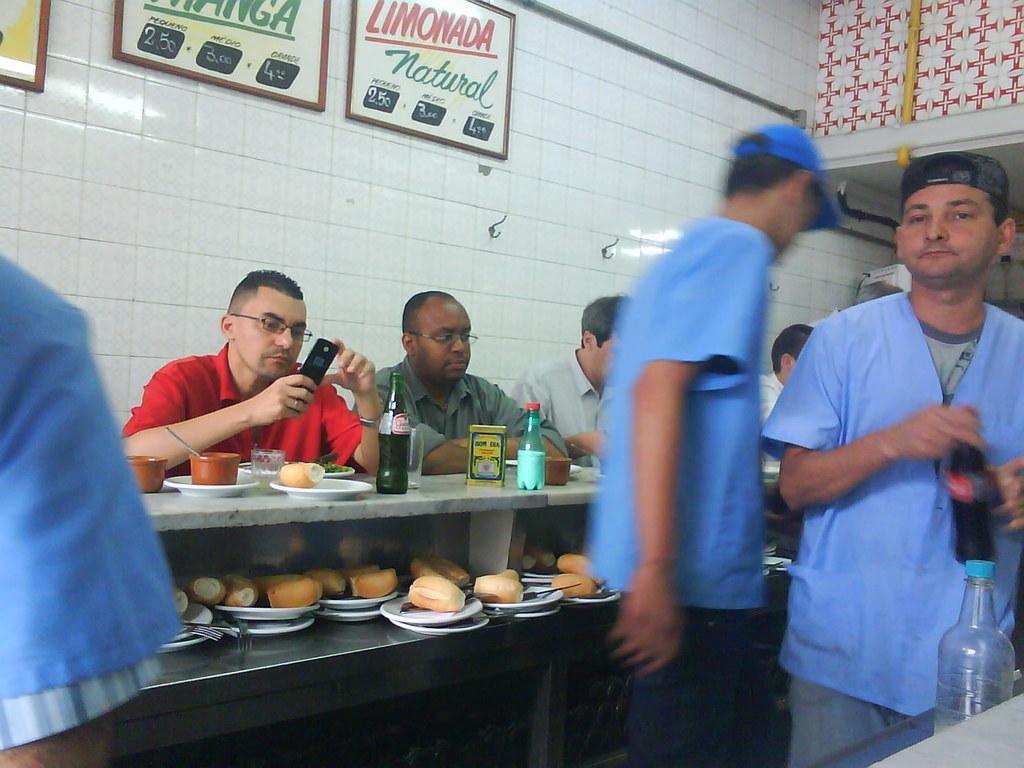Could you give a brief overview of what you see in this image? It looks like a cafe there are some people sitting in front of the table and having food,below that there are some other eatables kept on the plate and they are ready to be served,there are some people standing by wearing the uniform they are looking like servers in the cafe,in the background there is a white color wall with white tiles and some photo frames are stick to the wall. 